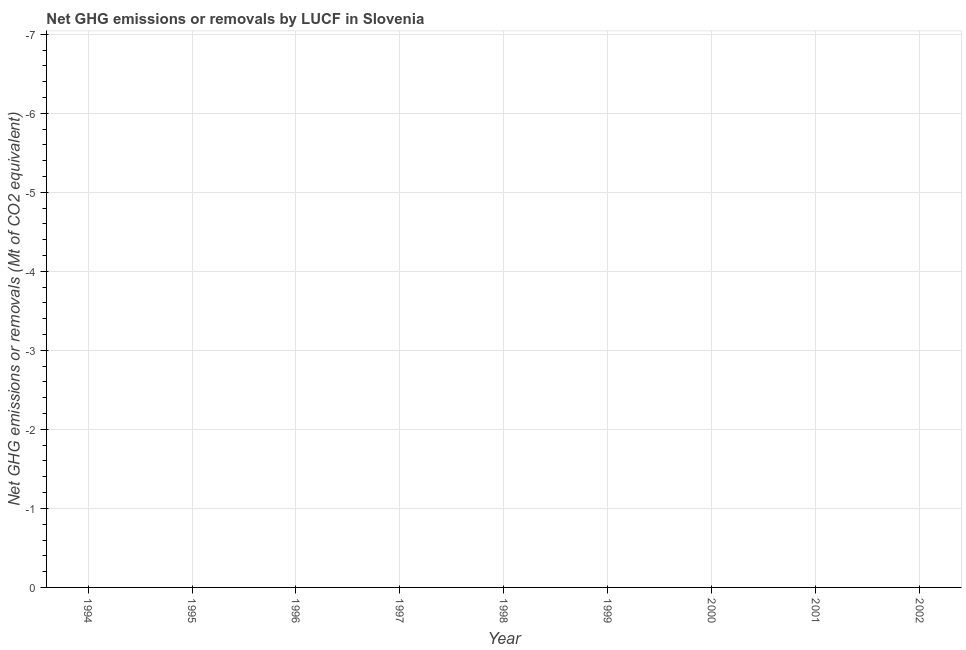What is the ghg net emissions or removals in 1994?
Give a very brief answer. 0. What is the median ghg net emissions or removals?
Keep it short and to the point. 0. In how many years, is the ghg net emissions or removals greater than -6.8 Mt?
Offer a terse response. 0. How many lines are there?
Offer a terse response. 0. What is the difference between two consecutive major ticks on the Y-axis?
Give a very brief answer. 1. Does the graph contain any zero values?
Your answer should be very brief. Yes. What is the title of the graph?
Your answer should be very brief. Net GHG emissions or removals by LUCF in Slovenia. What is the label or title of the X-axis?
Ensure brevity in your answer.  Year. What is the label or title of the Y-axis?
Your answer should be compact. Net GHG emissions or removals (Mt of CO2 equivalent). What is the Net GHG emissions or removals (Mt of CO2 equivalent) in 1999?
Keep it short and to the point. 0. What is the Net GHG emissions or removals (Mt of CO2 equivalent) in 2000?
Give a very brief answer. 0. 